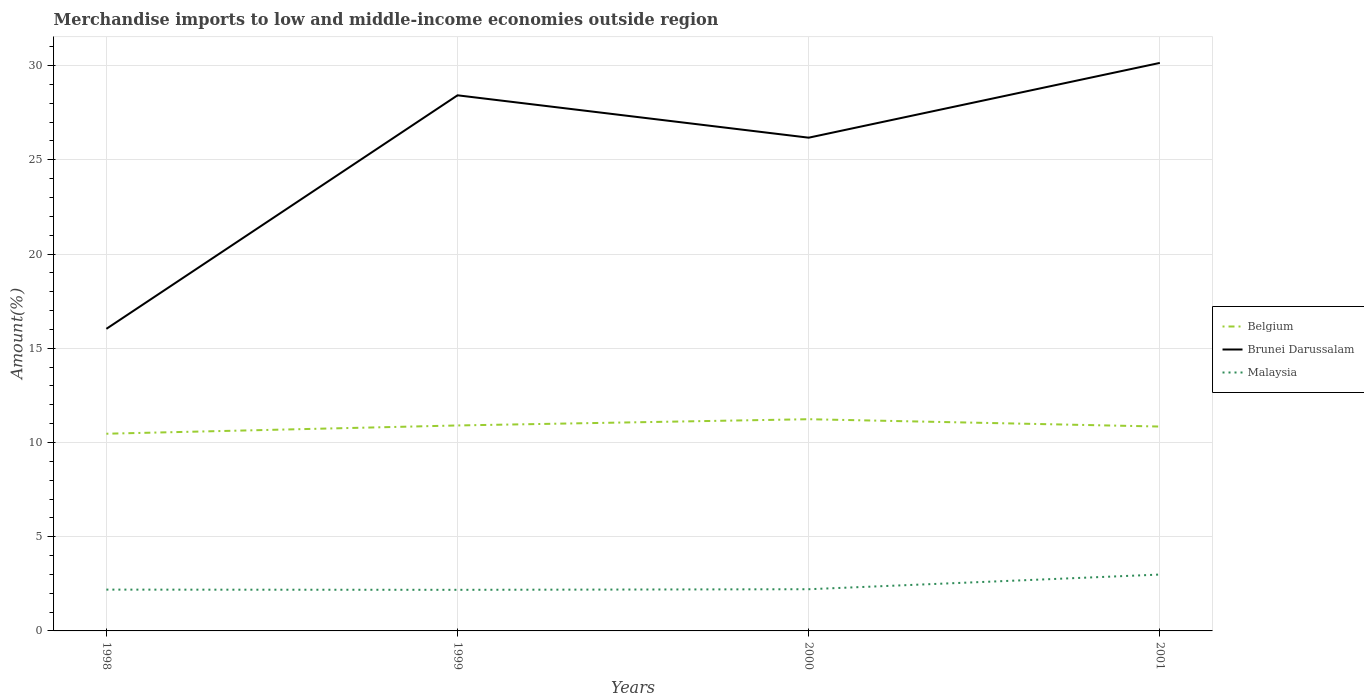How many different coloured lines are there?
Make the answer very short. 3. Does the line corresponding to Brunei Darussalam intersect with the line corresponding to Belgium?
Provide a short and direct response. No. Is the number of lines equal to the number of legend labels?
Your answer should be very brief. Yes. Across all years, what is the maximum percentage of amount earned from merchandise imports in Belgium?
Offer a very short reply. 10.46. What is the total percentage of amount earned from merchandise imports in Malaysia in the graph?
Offer a terse response. -0.81. What is the difference between the highest and the second highest percentage of amount earned from merchandise imports in Brunei Darussalam?
Your answer should be compact. 14.11. What is the difference between the highest and the lowest percentage of amount earned from merchandise imports in Malaysia?
Your answer should be compact. 1. How many years are there in the graph?
Your answer should be compact. 4. What is the difference between two consecutive major ticks on the Y-axis?
Ensure brevity in your answer.  5. Are the values on the major ticks of Y-axis written in scientific E-notation?
Keep it short and to the point. No. Where does the legend appear in the graph?
Your answer should be compact. Center right. How are the legend labels stacked?
Offer a terse response. Vertical. What is the title of the graph?
Provide a short and direct response. Merchandise imports to low and middle-income economies outside region. What is the label or title of the Y-axis?
Ensure brevity in your answer.  Amount(%). What is the Amount(%) of Belgium in 1998?
Your answer should be compact. 10.46. What is the Amount(%) in Brunei Darussalam in 1998?
Provide a succinct answer. 16.03. What is the Amount(%) of Malaysia in 1998?
Offer a very short reply. 2.19. What is the Amount(%) of Belgium in 1999?
Provide a succinct answer. 10.9. What is the Amount(%) of Brunei Darussalam in 1999?
Your response must be concise. 28.42. What is the Amount(%) of Malaysia in 1999?
Provide a succinct answer. 2.18. What is the Amount(%) in Belgium in 2000?
Your answer should be very brief. 11.23. What is the Amount(%) of Brunei Darussalam in 2000?
Make the answer very short. 26.17. What is the Amount(%) of Malaysia in 2000?
Offer a terse response. 2.21. What is the Amount(%) in Belgium in 2001?
Give a very brief answer. 10.84. What is the Amount(%) of Brunei Darussalam in 2001?
Offer a terse response. 30.14. What is the Amount(%) of Malaysia in 2001?
Give a very brief answer. 2.99. Across all years, what is the maximum Amount(%) in Belgium?
Provide a short and direct response. 11.23. Across all years, what is the maximum Amount(%) of Brunei Darussalam?
Provide a succinct answer. 30.14. Across all years, what is the maximum Amount(%) in Malaysia?
Ensure brevity in your answer.  2.99. Across all years, what is the minimum Amount(%) of Belgium?
Make the answer very short. 10.46. Across all years, what is the minimum Amount(%) in Brunei Darussalam?
Provide a succinct answer. 16.03. Across all years, what is the minimum Amount(%) of Malaysia?
Your answer should be very brief. 2.18. What is the total Amount(%) in Belgium in the graph?
Your response must be concise. 43.44. What is the total Amount(%) of Brunei Darussalam in the graph?
Your answer should be very brief. 100.76. What is the total Amount(%) in Malaysia in the graph?
Your response must be concise. 9.58. What is the difference between the Amount(%) of Belgium in 1998 and that in 1999?
Your response must be concise. -0.44. What is the difference between the Amount(%) of Brunei Darussalam in 1998 and that in 1999?
Provide a short and direct response. -12.39. What is the difference between the Amount(%) of Malaysia in 1998 and that in 1999?
Keep it short and to the point. 0.01. What is the difference between the Amount(%) in Belgium in 1998 and that in 2000?
Ensure brevity in your answer.  -0.77. What is the difference between the Amount(%) of Brunei Darussalam in 1998 and that in 2000?
Your response must be concise. -10.14. What is the difference between the Amount(%) in Malaysia in 1998 and that in 2000?
Offer a very short reply. -0.02. What is the difference between the Amount(%) of Belgium in 1998 and that in 2001?
Give a very brief answer. -0.38. What is the difference between the Amount(%) of Brunei Darussalam in 1998 and that in 2001?
Ensure brevity in your answer.  -14.11. What is the difference between the Amount(%) in Malaysia in 1998 and that in 2001?
Keep it short and to the point. -0.8. What is the difference between the Amount(%) in Belgium in 1999 and that in 2000?
Your answer should be very brief. -0.33. What is the difference between the Amount(%) in Brunei Darussalam in 1999 and that in 2000?
Your answer should be very brief. 2.25. What is the difference between the Amount(%) of Malaysia in 1999 and that in 2000?
Provide a succinct answer. -0.03. What is the difference between the Amount(%) of Belgium in 1999 and that in 2001?
Offer a very short reply. 0.06. What is the difference between the Amount(%) of Brunei Darussalam in 1999 and that in 2001?
Your answer should be very brief. -1.72. What is the difference between the Amount(%) in Malaysia in 1999 and that in 2001?
Give a very brief answer. -0.81. What is the difference between the Amount(%) of Belgium in 2000 and that in 2001?
Your answer should be compact. 0.39. What is the difference between the Amount(%) in Brunei Darussalam in 2000 and that in 2001?
Give a very brief answer. -3.97. What is the difference between the Amount(%) of Malaysia in 2000 and that in 2001?
Your answer should be compact. -0.78. What is the difference between the Amount(%) of Belgium in 1998 and the Amount(%) of Brunei Darussalam in 1999?
Your answer should be compact. -17.96. What is the difference between the Amount(%) in Belgium in 1998 and the Amount(%) in Malaysia in 1999?
Keep it short and to the point. 8.28. What is the difference between the Amount(%) in Brunei Darussalam in 1998 and the Amount(%) in Malaysia in 1999?
Provide a short and direct response. 13.85. What is the difference between the Amount(%) in Belgium in 1998 and the Amount(%) in Brunei Darussalam in 2000?
Your answer should be compact. -15.71. What is the difference between the Amount(%) in Belgium in 1998 and the Amount(%) in Malaysia in 2000?
Offer a very short reply. 8.25. What is the difference between the Amount(%) of Brunei Darussalam in 1998 and the Amount(%) of Malaysia in 2000?
Your response must be concise. 13.82. What is the difference between the Amount(%) in Belgium in 1998 and the Amount(%) in Brunei Darussalam in 2001?
Offer a terse response. -19.68. What is the difference between the Amount(%) in Belgium in 1998 and the Amount(%) in Malaysia in 2001?
Your response must be concise. 7.47. What is the difference between the Amount(%) of Brunei Darussalam in 1998 and the Amount(%) of Malaysia in 2001?
Offer a terse response. 13.04. What is the difference between the Amount(%) of Belgium in 1999 and the Amount(%) of Brunei Darussalam in 2000?
Provide a short and direct response. -15.27. What is the difference between the Amount(%) of Belgium in 1999 and the Amount(%) of Malaysia in 2000?
Your answer should be compact. 8.69. What is the difference between the Amount(%) in Brunei Darussalam in 1999 and the Amount(%) in Malaysia in 2000?
Your answer should be compact. 26.21. What is the difference between the Amount(%) in Belgium in 1999 and the Amount(%) in Brunei Darussalam in 2001?
Offer a very short reply. -19.24. What is the difference between the Amount(%) of Belgium in 1999 and the Amount(%) of Malaysia in 2001?
Give a very brief answer. 7.91. What is the difference between the Amount(%) in Brunei Darussalam in 1999 and the Amount(%) in Malaysia in 2001?
Ensure brevity in your answer.  25.43. What is the difference between the Amount(%) in Belgium in 2000 and the Amount(%) in Brunei Darussalam in 2001?
Provide a succinct answer. -18.91. What is the difference between the Amount(%) in Belgium in 2000 and the Amount(%) in Malaysia in 2001?
Make the answer very short. 8.24. What is the difference between the Amount(%) of Brunei Darussalam in 2000 and the Amount(%) of Malaysia in 2001?
Your answer should be very brief. 23.18. What is the average Amount(%) in Belgium per year?
Ensure brevity in your answer.  10.86. What is the average Amount(%) of Brunei Darussalam per year?
Give a very brief answer. 25.19. What is the average Amount(%) in Malaysia per year?
Your response must be concise. 2.39. In the year 1998, what is the difference between the Amount(%) in Belgium and Amount(%) in Brunei Darussalam?
Provide a succinct answer. -5.57. In the year 1998, what is the difference between the Amount(%) of Belgium and Amount(%) of Malaysia?
Ensure brevity in your answer.  8.27. In the year 1998, what is the difference between the Amount(%) in Brunei Darussalam and Amount(%) in Malaysia?
Ensure brevity in your answer.  13.84. In the year 1999, what is the difference between the Amount(%) of Belgium and Amount(%) of Brunei Darussalam?
Make the answer very short. -17.52. In the year 1999, what is the difference between the Amount(%) of Belgium and Amount(%) of Malaysia?
Offer a very short reply. 8.72. In the year 1999, what is the difference between the Amount(%) of Brunei Darussalam and Amount(%) of Malaysia?
Give a very brief answer. 26.24. In the year 2000, what is the difference between the Amount(%) of Belgium and Amount(%) of Brunei Darussalam?
Your response must be concise. -14.94. In the year 2000, what is the difference between the Amount(%) in Belgium and Amount(%) in Malaysia?
Your answer should be very brief. 9.02. In the year 2000, what is the difference between the Amount(%) in Brunei Darussalam and Amount(%) in Malaysia?
Your response must be concise. 23.96. In the year 2001, what is the difference between the Amount(%) of Belgium and Amount(%) of Brunei Darussalam?
Your answer should be compact. -19.3. In the year 2001, what is the difference between the Amount(%) of Belgium and Amount(%) of Malaysia?
Your answer should be compact. 7.85. In the year 2001, what is the difference between the Amount(%) in Brunei Darussalam and Amount(%) in Malaysia?
Make the answer very short. 27.15. What is the ratio of the Amount(%) of Belgium in 1998 to that in 1999?
Keep it short and to the point. 0.96. What is the ratio of the Amount(%) in Brunei Darussalam in 1998 to that in 1999?
Your answer should be very brief. 0.56. What is the ratio of the Amount(%) in Malaysia in 1998 to that in 1999?
Your response must be concise. 1.01. What is the ratio of the Amount(%) in Belgium in 1998 to that in 2000?
Make the answer very short. 0.93. What is the ratio of the Amount(%) in Brunei Darussalam in 1998 to that in 2000?
Make the answer very short. 0.61. What is the ratio of the Amount(%) in Malaysia in 1998 to that in 2000?
Give a very brief answer. 0.99. What is the ratio of the Amount(%) in Belgium in 1998 to that in 2001?
Offer a terse response. 0.96. What is the ratio of the Amount(%) in Brunei Darussalam in 1998 to that in 2001?
Your answer should be compact. 0.53. What is the ratio of the Amount(%) of Malaysia in 1998 to that in 2001?
Offer a terse response. 0.73. What is the ratio of the Amount(%) in Belgium in 1999 to that in 2000?
Make the answer very short. 0.97. What is the ratio of the Amount(%) in Brunei Darussalam in 1999 to that in 2000?
Make the answer very short. 1.09. What is the ratio of the Amount(%) in Malaysia in 1999 to that in 2000?
Provide a succinct answer. 0.99. What is the ratio of the Amount(%) of Belgium in 1999 to that in 2001?
Give a very brief answer. 1.01. What is the ratio of the Amount(%) in Brunei Darussalam in 1999 to that in 2001?
Offer a very short reply. 0.94. What is the ratio of the Amount(%) in Malaysia in 1999 to that in 2001?
Provide a short and direct response. 0.73. What is the ratio of the Amount(%) in Belgium in 2000 to that in 2001?
Keep it short and to the point. 1.04. What is the ratio of the Amount(%) in Brunei Darussalam in 2000 to that in 2001?
Offer a terse response. 0.87. What is the ratio of the Amount(%) of Malaysia in 2000 to that in 2001?
Offer a terse response. 0.74. What is the difference between the highest and the second highest Amount(%) in Belgium?
Offer a terse response. 0.33. What is the difference between the highest and the second highest Amount(%) in Brunei Darussalam?
Your response must be concise. 1.72. What is the difference between the highest and the second highest Amount(%) of Malaysia?
Provide a short and direct response. 0.78. What is the difference between the highest and the lowest Amount(%) of Belgium?
Provide a succinct answer. 0.77. What is the difference between the highest and the lowest Amount(%) of Brunei Darussalam?
Provide a succinct answer. 14.11. What is the difference between the highest and the lowest Amount(%) in Malaysia?
Ensure brevity in your answer.  0.81. 